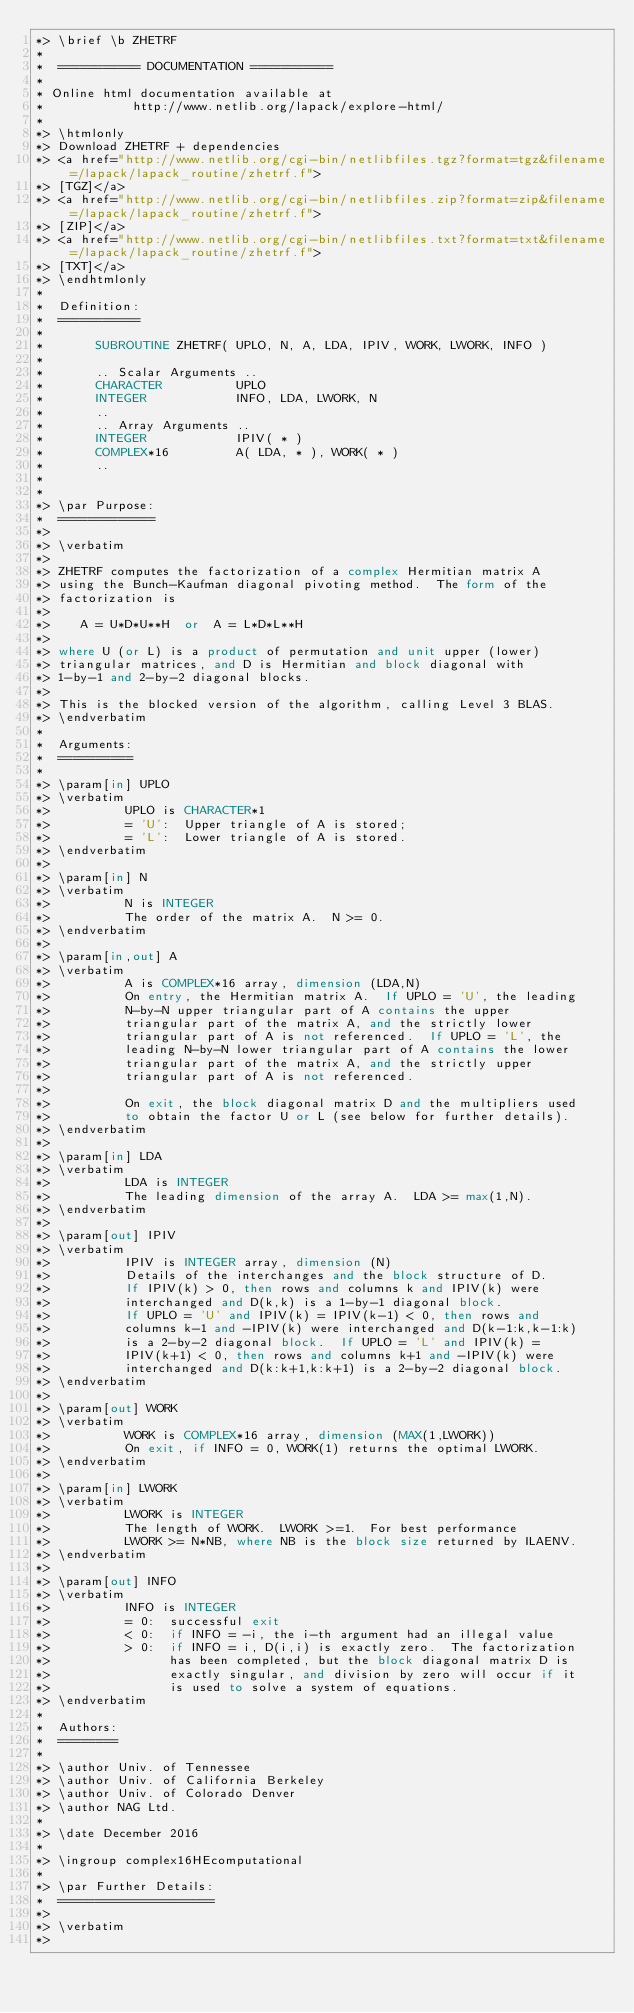<code> <loc_0><loc_0><loc_500><loc_500><_FORTRAN_>*> \brief \b ZHETRF
*
*  =========== DOCUMENTATION ===========
*
* Online html documentation available at
*            http://www.netlib.org/lapack/explore-html/
*
*> \htmlonly
*> Download ZHETRF + dependencies
*> <a href="http://www.netlib.org/cgi-bin/netlibfiles.tgz?format=tgz&filename=/lapack/lapack_routine/zhetrf.f">
*> [TGZ]</a>
*> <a href="http://www.netlib.org/cgi-bin/netlibfiles.zip?format=zip&filename=/lapack/lapack_routine/zhetrf.f">
*> [ZIP]</a>
*> <a href="http://www.netlib.org/cgi-bin/netlibfiles.txt?format=txt&filename=/lapack/lapack_routine/zhetrf.f">
*> [TXT]</a>
*> \endhtmlonly
*
*  Definition:
*  ===========
*
*       SUBROUTINE ZHETRF( UPLO, N, A, LDA, IPIV, WORK, LWORK, INFO )
*
*       .. Scalar Arguments ..
*       CHARACTER          UPLO
*       INTEGER            INFO, LDA, LWORK, N
*       ..
*       .. Array Arguments ..
*       INTEGER            IPIV( * )
*       COMPLEX*16         A( LDA, * ), WORK( * )
*       ..
*
*
*> \par Purpose:
*  =============
*>
*> \verbatim
*>
*> ZHETRF computes the factorization of a complex Hermitian matrix A
*> using the Bunch-Kaufman diagonal pivoting method.  The form of the
*> factorization is
*>
*>    A = U*D*U**H  or  A = L*D*L**H
*>
*> where U (or L) is a product of permutation and unit upper (lower)
*> triangular matrices, and D is Hermitian and block diagonal with
*> 1-by-1 and 2-by-2 diagonal blocks.
*>
*> This is the blocked version of the algorithm, calling Level 3 BLAS.
*> \endverbatim
*
*  Arguments:
*  ==========
*
*> \param[in] UPLO
*> \verbatim
*>          UPLO is CHARACTER*1
*>          = 'U':  Upper triangle of A is stored;
*>          = 'L':  Lower triangle of A is stored.
*> \endverbatim
*>
*> \param[in] N
*> \verbatim
*>          N is INTEGER
*>          The order of the matrix A.  N >= 0.
*> \endverbatim
*>
*> \param[in,out] A
*> \verbatim
*>          A is COMPLEX*16 array, dimension (LDA,N)
*>          On entry, the Hermitian matrix A.  If UPLO = 'U', the leading
*>          N-by-N upper triangular part of A contains the upper
*>          triangular part of the matrix A, and the strictly lower
*>          triangular part of A is not referenced.  If UPLO = 'L', the
*>          leading N-by-N lower triangular part of A contains the lower
*>          triangular part of the matrix A, and the strictly upper
*>          triangular part of A is not referenced.
*>
*>          On exit, the block diagonal matrix D and the multipliers used
*>          to obtain the factor U or L (see below for further details).
*> \endverbatim
*>
*> \param[in] LDA
*> \verbatim
*>          LDA is INTEGER
*>          The leading dimension of the array A.  LDA >= max(1,N).
*> \endverbatim
*>
*> \param[out] IPIV
*> \verbatim
*>          IPIV is INTEGER array, dimension (N)
*>          Details of the interchanges and the block structure of D.
*>          If IPIV(k) > 0, then rows and columns k and IPIV(k) were
*>          interchanged and D(k,k) is a 1-by-1 diagonal block.
*>          If UPLO = 'U' and IPIV(k) = IPIV(k-1) < 0, then rows and
*>          columns k-1 and -IPIV(k) were interchanged and D(k-1:k,k-1:k)
*>          is a 2-by-2 diagonal block.  If UPLO = 'L' and IPIV(k) =
*>          IPIV(k+1) < 0, then rows and columns k+1 and -IPIV(k) were
*>          interchanged and D(k:k+1,k:k+1) is a 2-by-2 diagonal block.
*> \endverbatim
*>
*> \param[out] WORK
*> \verbatim
*>          WORK is COMPLEX*16 array, dimension (MAX(1,LWORK))
*>          On exit, if INFO = 0, WORK(1) returns the optimal LWORK.
*> \endverbatim
*>
*> \param[in] LWORK
*> \verbatim
*>          LWORK is INTEGER
*>          The length of WORK.  LWORK >=1.  For best performance
*>          LWORK >= N*NB, where NB is the block size returned by ILAENV.
*> \endverbatim
*>
*> \param[out] INFO
*> \verbatim
*>          INFO is INTEGER
*>          = 0:  successful exit
*>          < 0:  if INFO = -i, the i-th argument had an illegal value
*>          > 0:  if INFO = i, D(i,i) is exactly zero.  The factorization
*>                has been completed, but the block diagonal matrix D is
*>                exactly singular, and division by zero will occur if it
*>                is used to solve a system of equations.
*> \endverbatim
*
*  Authors:
*  ========
*
*> \author Univ. of Tennessee
*> \author Univ. of California Berkeley
*> \author Univ. of Colorado Denver
*> \author NAG Ltd.
*
*> \date December 2016
*
*> \ingroup complex16HEcomputational
*
*> \par Further Details:
*  =====================
*>
*> \verbatim
*></code> 